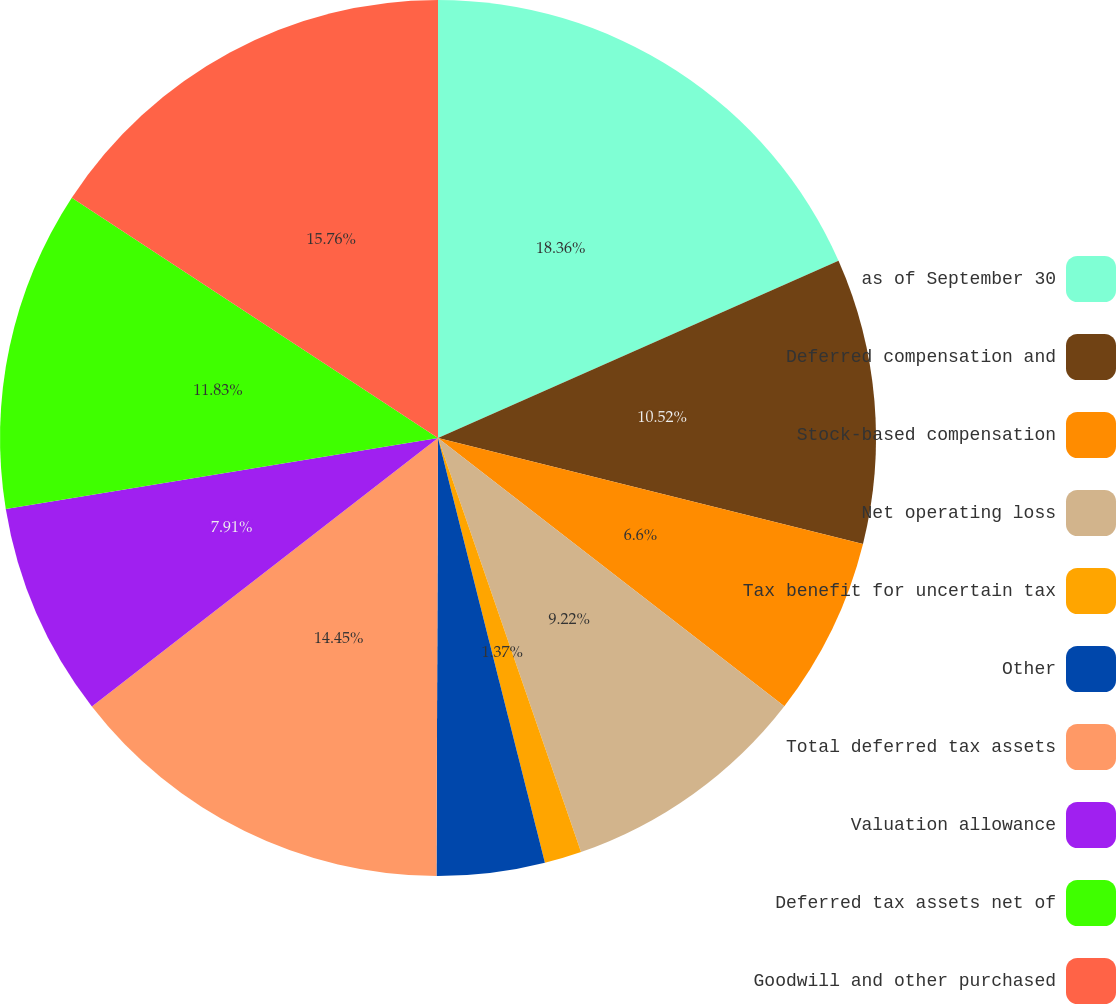Convert chart to OTSL. <chart><loc_0><loc_0><loc_500><loc_500><pie_chart><fcel>as of September 30<fcel>Deferred compensation and<fcel>Stock-based compensation<fcel>Net operating loss<fcel>Tax benefit for uncertain tax<fcel>Other<fcel>Total deferred tax assets<fcel>Valuation allowance<fcel>Deferred tax assets net of<fcel>Goodwill and other purchased<nl><fcel>18.37%<fcel>10.52%<fcel>6.6%<fcel>9.22%<fcel>1.37%<fcel>3.98%<fcel>14.45%<fcel>7.91%<fcel>11.83%<fcel>15.76%<nl></chart> 